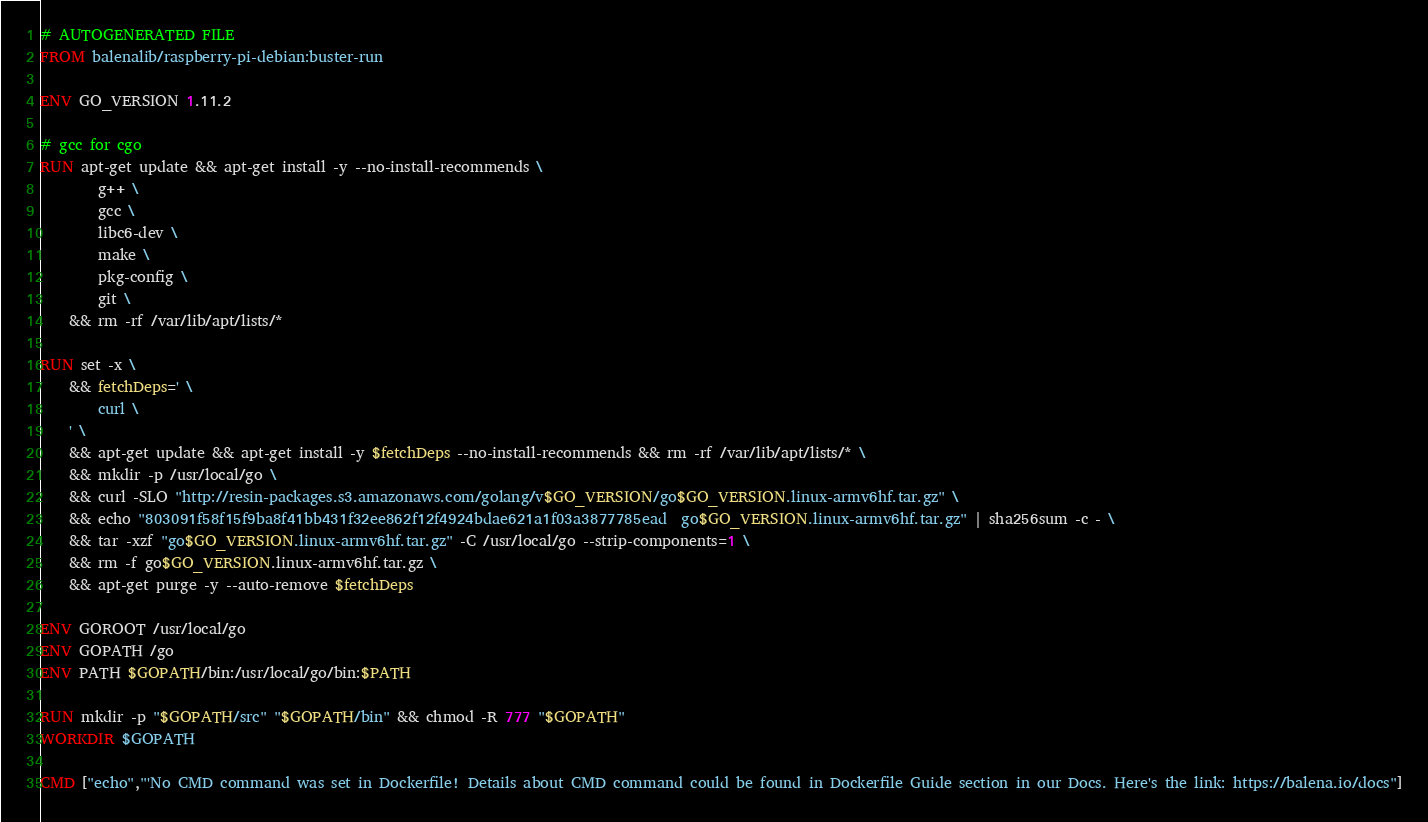Convert code to text. <code><loc_0><loc_0><loc_500><loc_500><_Dockerfile_># AUTOGENERATED FILE
FROM balenalib/raspberry-pi-debian:buster-run

ENV GO_VERSION 1.11.2

# gcc for cgo
RUN apt-get update && apt-get install -y --no-install-recommends \
		g++ \
		gcc \
		libc6-dev \
		make \
		pkg-config \
		git \
	&& rm -rf /var/lib/apt/lists/*

RUN set -x \
	&& fetchDeps=' \
		curl \
	' \
	&& apt-get update && apt-get install -y $fetchDeps --no-install-recommends && rm -rf /var/lib/apt/lists/* \
	&& mkdir -p /usr/local/go \
	&& curl -SLO "http://resin-packages.s3.amazonaws.com/golang/v$GO_VERSION/go$GO_VERSION.linux-armv6hf.tar.gz" \
	&& echo "803091f58f15f9ba8f41bb431f32ee862f12f4924bdae621a1f03a3877785ead  go$GO_VERSION.linux-armv6hf.tar.gz" | sha256sum -c - \
	&& tar -xzf "go$GO_VERSION.linux-armv6hf.tar.gz" -C /usr/local/go --strip-components=1 \
	&& rm -f go$GO_VERSION.linux-armv6hf.tar.gz \
	&& apt-get purge -y --auto-remove $fetchDeps

ENV GOROOT /usr/local/go
ENV GOPATH /go
ENV PATH $GOPATH/bin:/usr/local/go/bin:$PATH

RUN mkdir -p "$GOPATH/src" "$GOPATH/bin" && chmod -R 777 "$GOPATH"
WORKDIR $GOPATH

CMD ["echo","'No CMD command was set in Dockerfile! Details about CMD command could be found in Dockerfile Guide section in our Docs. Here's the link: https://balena.io/docs"]</code> 